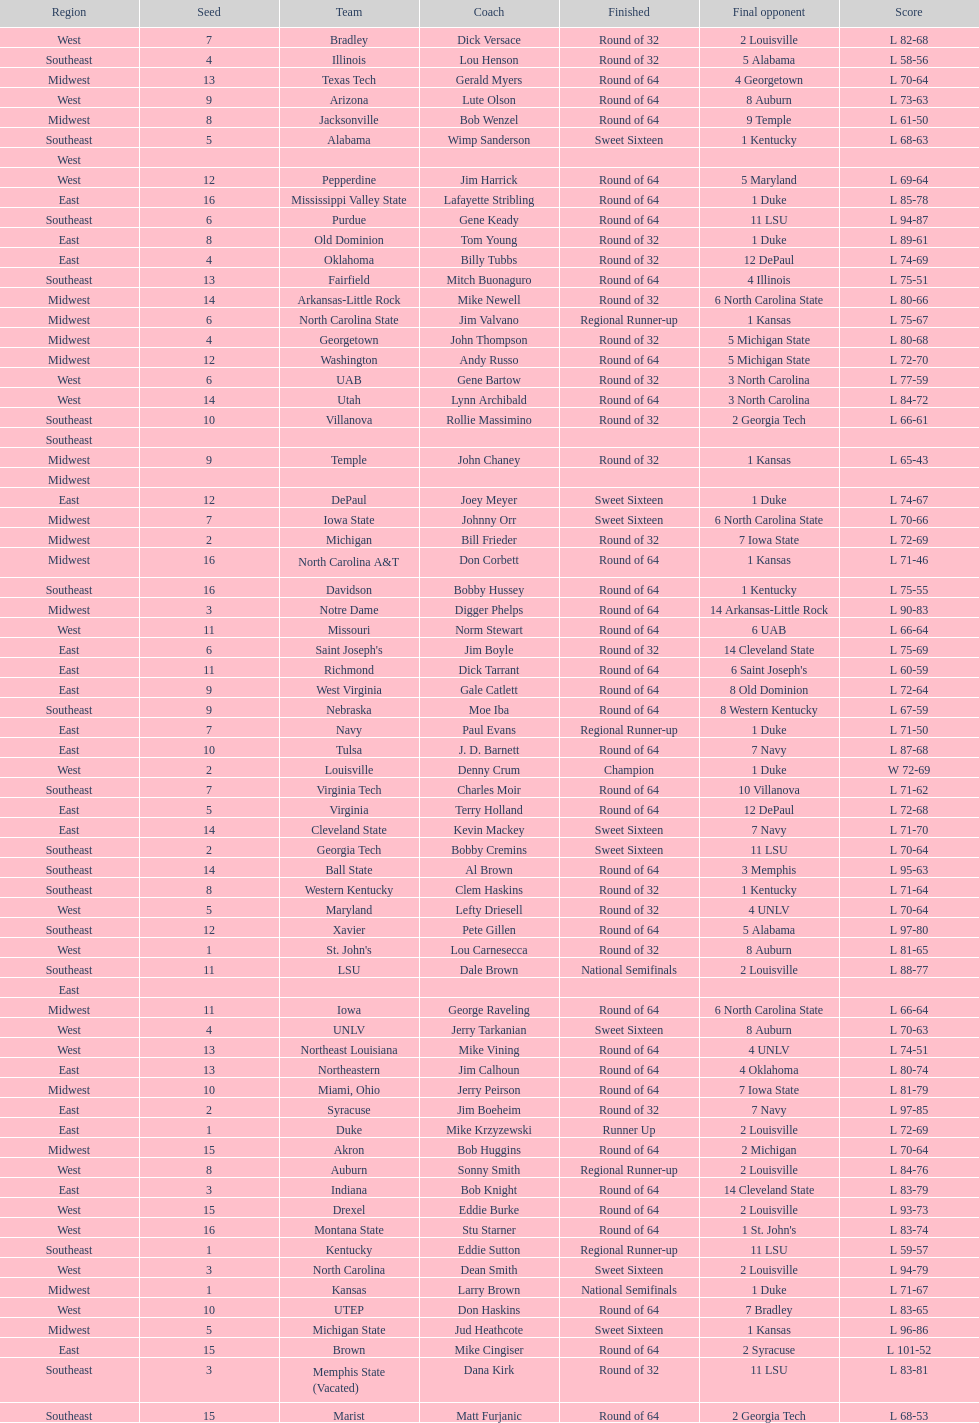Who is the only team from the east region to reach the final round? Duke. 